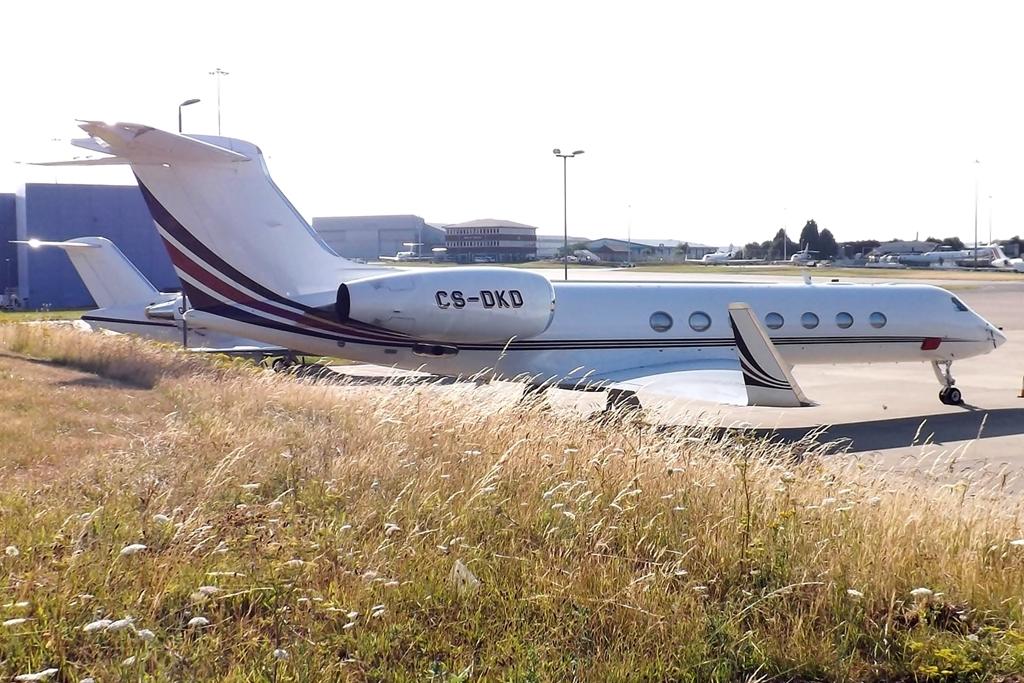What is written on the side of this airplane?
Keep it short and to the point. Cs-dkd. What number is on the plane?
Ensure brevity in your answer.  Cs-dkd. 